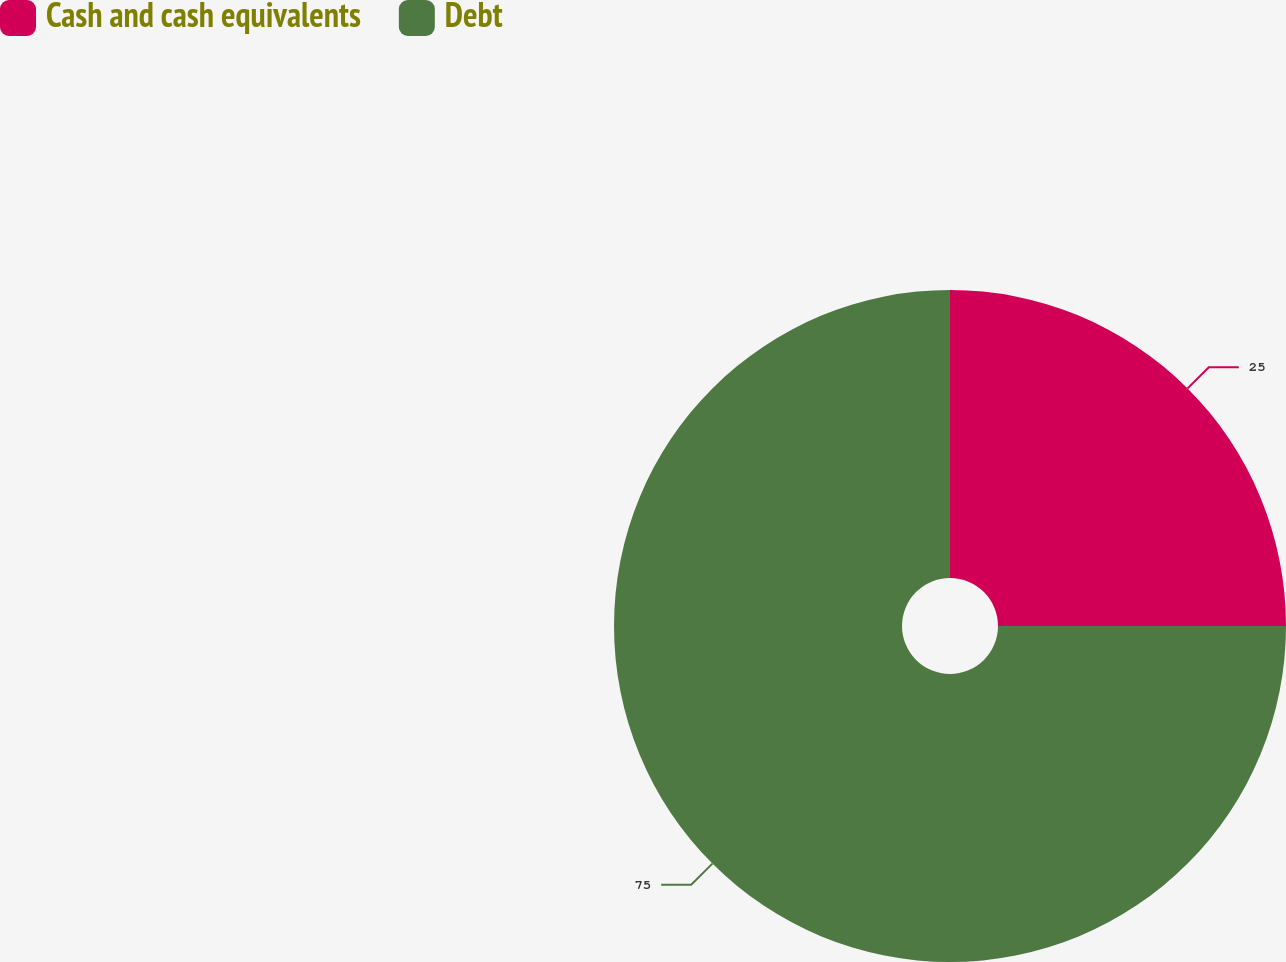Convert chart. <chart><loc_0><loc_0><loc_500><loc_500><pie_chart><fcel>Cash and cash equivalents<fcel>Debt<nl><fcel>25.0%<fcel>75.0%<nl></chart> 